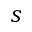Convert formula to latex. <formula><loc_0><loc_0><loc_500><loc_500>s</formula> 